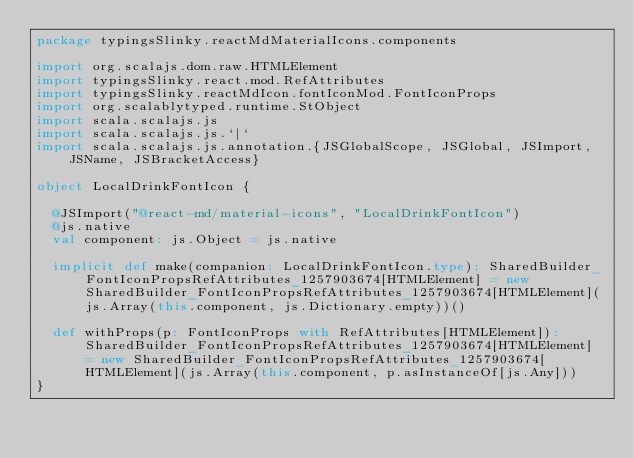Convert code to text. <code><loc_0><loc_0><loc_500><loc_500><_Scala_>package typingsSlinky.reactMdMaterialIcons.components

import org.scalajs.dom.raw.HTMLElement
import typingsSlinky.react.mod.RefAttributes
import typingsSlinky.reactMdIcon.fontIconMod.FontIconProps
import org.scalablytyped.runtime.StObject
import scala.scalajs.js
import scala.scalajs.js.`|`
import scala.scalajs.js.annotation.{JSGlobalScope, JSGlobal, JSImport, JSName, JSBracketAccess}

object LocalDrinkFontIcon {
  
  @JSImport("@react-md/material-icons", "LocalDrinkFontIcon")
  @js.native
  val component: js.Object = js.native
  
  implicit def make(companion: LocalDrinkFontIcon.type): SharedBuilder_FontIconPropsRefAttributes_1257903674[HTMLElement] = new SharedBuilder_FontIconPropsRefAttributes_1257903674[HTMLElement](js.Array(this.component, js.Dictionary.empty))()
  
  def withProps(p: FontIconProps with RefAttributes[HTMLElement]): SharedBuilder_FontIconPropsRefAttributes_1257903674[HTMLElement] = new SharedBuilder_FontIconPropsRefAttributes_1257903674[HTMLElement](js.Array(this.component, p.asInstanceOf[js.Any]))
}
</code> 